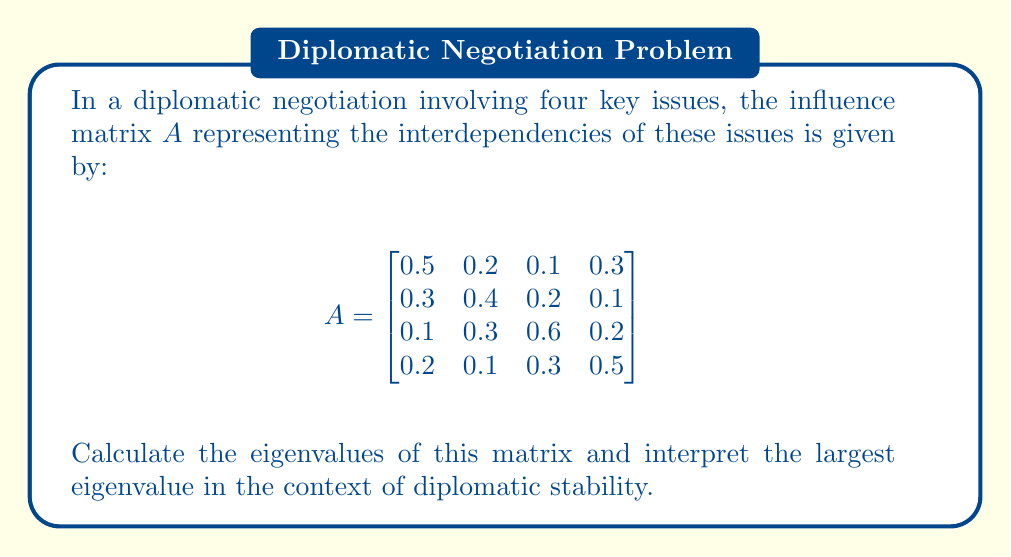Give your solution to this math problem. To find the eigenvalues of matrix $A$, we need to solve the characteristic equation:

$$\det(A - \lambda I) = 0$$

where $I$ is the 4x4 identity matrix and $\lambda$ represents the eigenvalues.

Step 1: Set up the characteristic equation:
$$\begin{vmatrix}
0.5-\lambda & 0.2 & 0.1 & 0.3 \\
0.3 & 0.4-\lambda & 0.2 & 0.1 \\
0.1 & 0.3 & 0.6-\lambda & 0.2 \\
0.2 & 0.1 & 0.3 & 0.5-\lambda
\end{vmatrix} = 0$$

Step 2: Expand the determinant (this is a complex calculation, so we'll use a computer algebra system):

$$(0.5-\lambda)(0.4-\lambda)(0.6-\lambda)(0.5-\lambda) - 0.006(0.5-\lambda) - 0.018(0.4-\lambda) - 0.009(0.6-\lambda) - 0.012(0.5-\lambda) + 0.0145 = 0$$

Step 3: Simplify the equation:

$$\lambda^4 - 2\lambda^3 + 1.1742\lambda^2 - 0.2298\lambda + 0.0145 = 0$$

Step 4: Solve this equation using numerical methods. The eigenvalues are approximately:

$$\lambda_1 \approx 1.0396$$
$$\lambda_2 \approx 0.4868$$
$$\lambda_3 \approx 0.2736$$
$$\lambda_4 \approx 0.2000$$

Step 5: Interpret the largest eigenvalue ($\lambda_1 \approx 1.0396$):

In the context of diplomatic negotiations, the largest eigenvalue being slightly greater than 1 suggests that the system is marginally unstable. This indicates that small perturbations in the negotiation process could lead to amplified effects over time, potentially making the diplomatic situation more challenging to manage.
Answer: Eigenvalues: 1.0396, 0.4868, 0.2736, 0.2000. Largest eigenvalue (1.0396) indicates marginal instability in negotiations. 